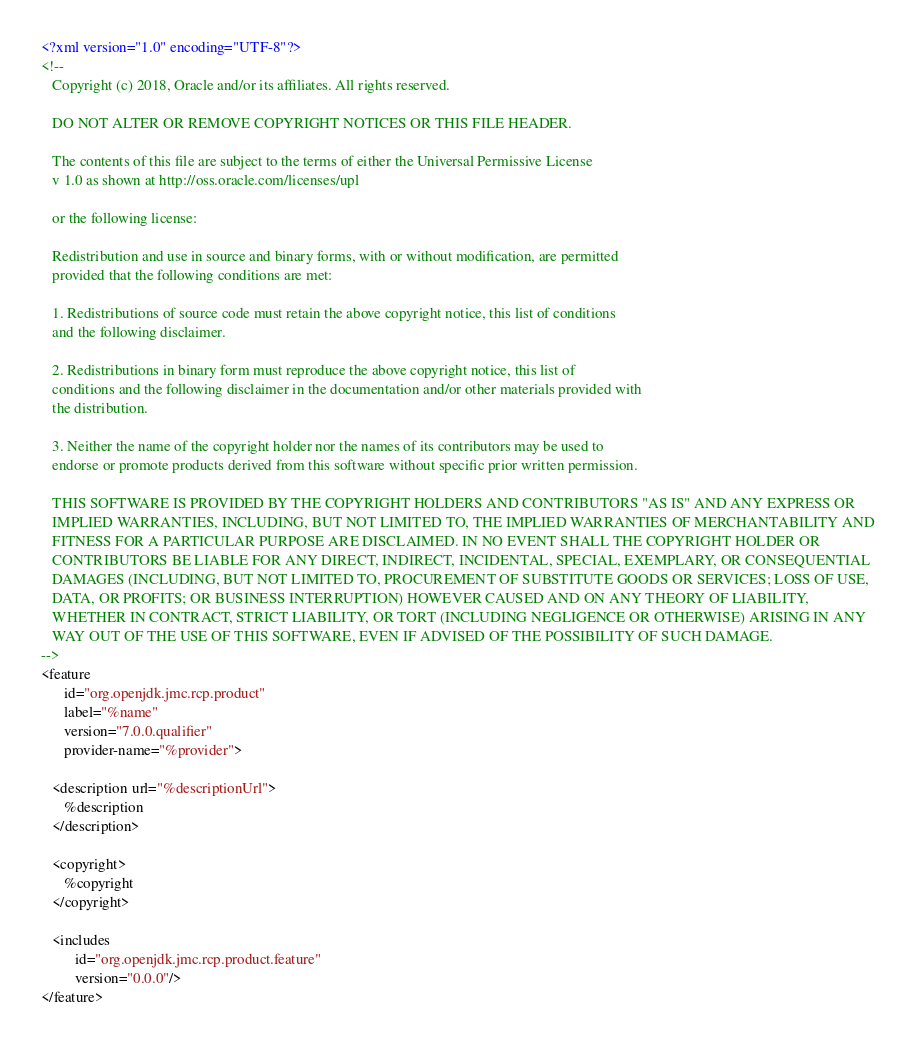<code> <loc_0><loc_0><loc_500><loc_500><_XML_><?xml version="1.0" encoding="UTF-8"?>
<!--   
   Copyright (c) 2018, Oracle and/or its affiliates. All rights reserved.
   
   DO NOT ALTER OR REMOVE COPYRIGHT NOTICES OR THIS FILE HEADER.
   
   The contents of this file are subject to the terms of either the Universal Permissive License 
   v 1.0 as shown at http://oss.oracle.com/licenses/upl
   
   or the following license:
   
   Redistribution and use in source and binary forms, with or without modification, are permitted
   provided that the following conditions are met:
   
   1. Redistributions of source code must retain the above copyright notice, this list of conditions
   and the following disclaimer.
   
   2. Redistributions in binary form must reproduce the above copyright notice, this list of
   conditions and the following disclaimer in the documentation and/or other materials provided with
   the distribution.
   
   3. Neither the name of the copyright holder nor the names of its contributors may be used to
   endorse or promote products derived from this software without specific prior written permission.
   
   THIS SOFTWARE IS PROVIDED BY THE COPYRIGHT HOLDERS AND CONTRIBUTORS "AS IS" AND ANY EXPRESS OR
   IMPLIED WARRANTIES, INCLUDING, BUT NOT LIMITED TO, THE IMPLIED WARRANTIES OF MERCHANTABILITY AND
   FITNESS FOR A PARTICULAR PURPOSE ARE DISCLAIMED. IN NO EVENT SHALL THE COPYRIGHT HOLDER OR
   CONTRIBUTORS BE LIABLE FOR ANY DIRECT, INDIRECT, INCIDENTAL, SPECIAL, EXEMPLARY, OR CONSEQUENTIAL
   DAMAGES (INCLUDING, BUT NOT LIMITED TO, PROCUREMENT OF SUBSTITUTE GOODS OR SERVICES; LOSS OF USE,
   DATA, OR PROFITS; OR BUSINESS INTERRUPTION) HOWEVER CAUSED AND ON ANY THEORY OF LIABILITY,
   WHETHER IN CONTRACT, STRICT LIABILITY, OR TORT (INCLUDING NEGLIGENCE OR OTHERWISE) ARISING IN ANY
   WAY OUT OF THE USE OF THIS SOFTWARE, EVEN IF ADVISED OF THE POSSIBILITY OF SUCH DAMAGE.
-->
<feature
      id="org.openjdk.jmc.rcp.product"
      label="%name"
      version="7.0.0.qualifier"
      provider-name="%provider">

   <description url="%descriptionUrl">
      %description
   </description>

   <copyright>
      %copyright
   </copyright>

   <includes
         id="org.openjdk.jmc.rcp.product.feature"
         version="0.0.0"/>
</feature></code> 